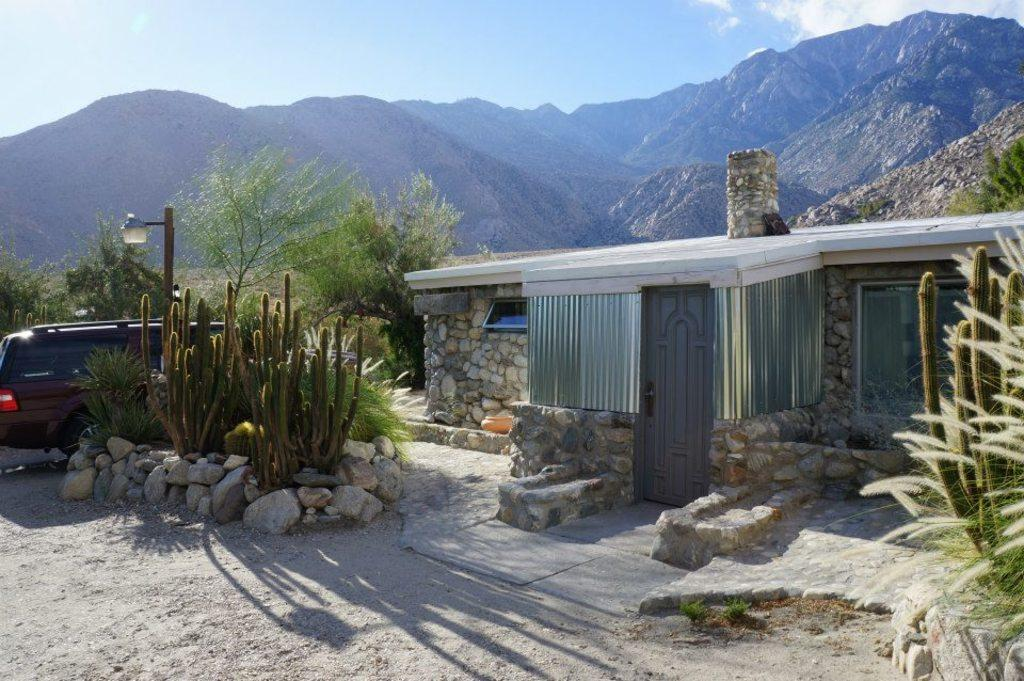What type of natural formation can be seen in the image? There are mountains in the image. What type of dwelling is present in the image? There is a house in the image. What type of plants can be seen in the image? Cactus plants and grass plants are visible in the image. What type of vegetation is present in the image? Trees are present in the image. What type of transportation is visible in the image? There is a vehicle in the image. What type of man-made structure is visible in the image? A light pole is visible in the image. What type of ground cover is present in the image? Stones are present in the image. What part of the natural environment is visible in the image? The sky is visible in the image. What type of cake is being served at the party in the image? There is no party or cake present in the image. What type of machine is being used to create the joke in the image? There is no joke or machine present in the image. 